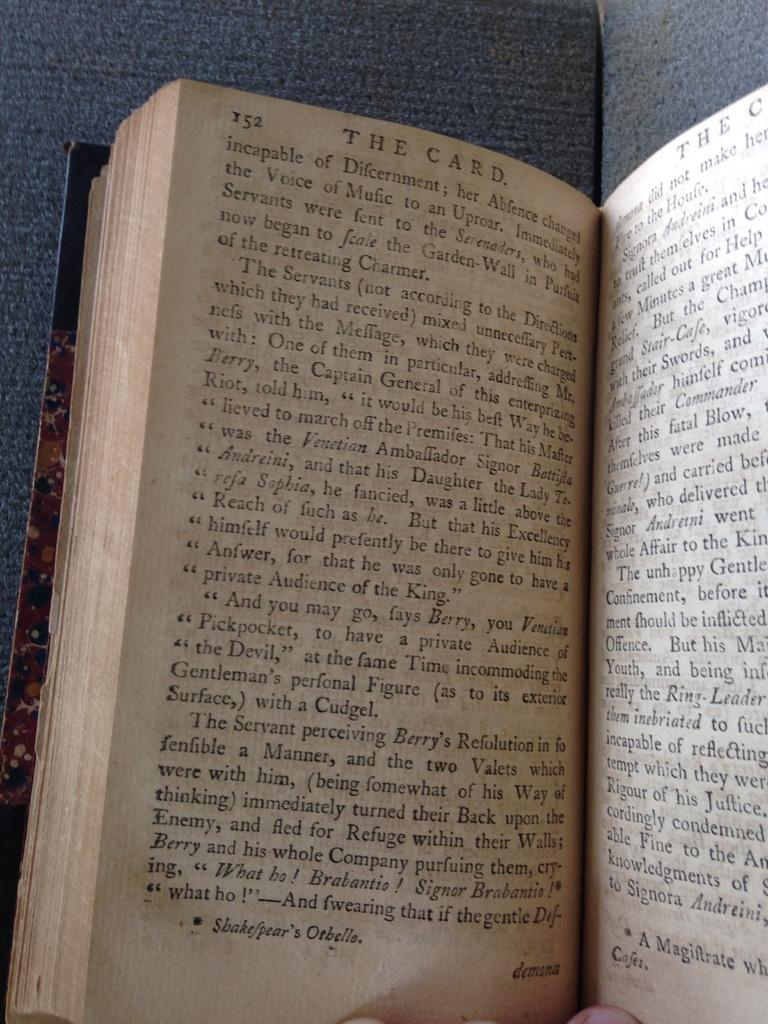<image>
Create a compact narrative representing the image presented. A person holding an open book called The Card. 